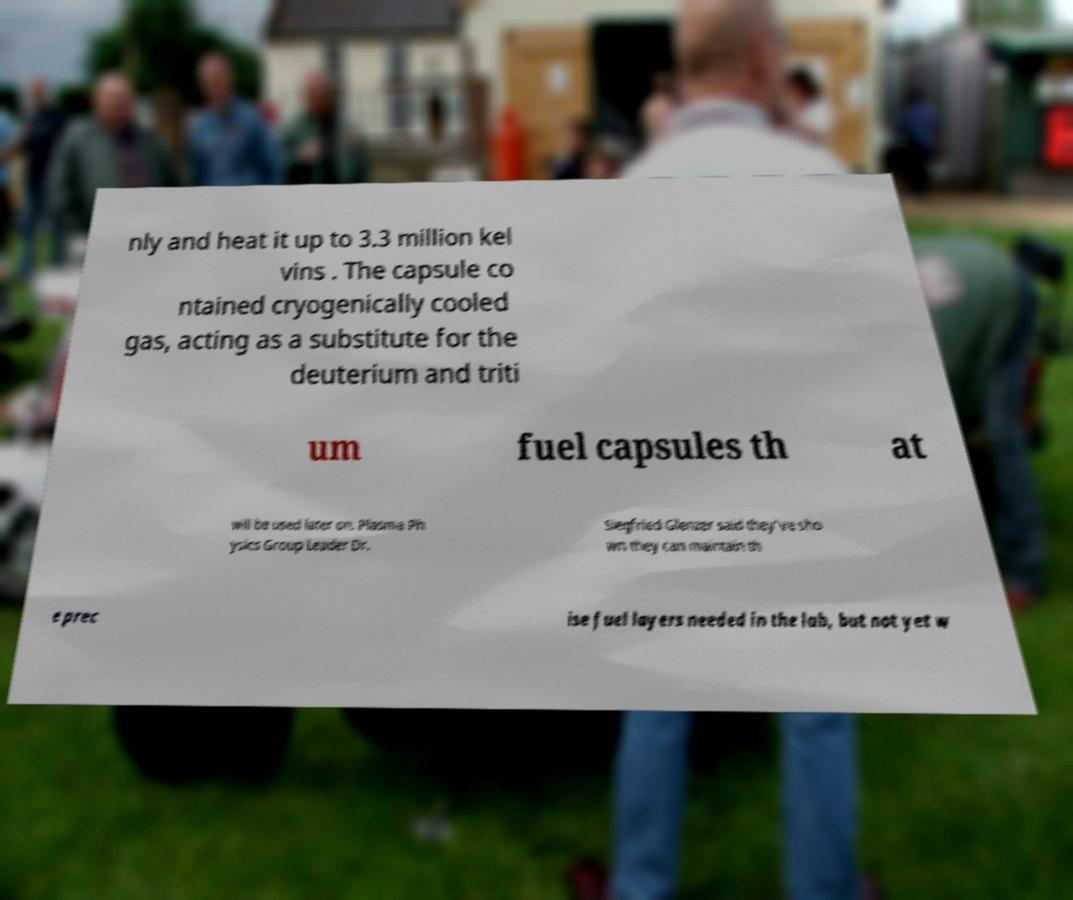Could you extract and type out the text from this image? nly and heat it up to 3.3 million kel vins . The capsule co ntained cryogenically cooled gas, acting as a substitute for the deuterium and triti um fuel capsules th at will be used later on. Plasma Ph ysics Group Leader Dr. Siegfried Glenzer said they've sho wn they can maintain th e prec ise fuel layers needed in the lab, but not yet w 